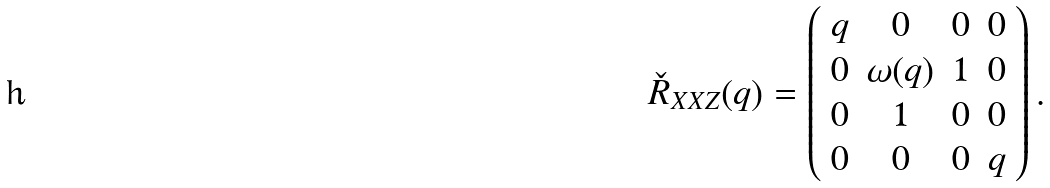Convert formula to latex. <formula><loc_0><loc_0><loc_500><loc_500>\check { R } _ { X X Z } ( q ) = \left ( \begin{array} { c c c c } q & 0 & 0 & 0 \\ 0 & \omega ( q ) & 1 & 0 \\ 0 & 1 & 0 & 0 \\ 0 & 0 & 0 & q \end{array} \right ) .</formula> 